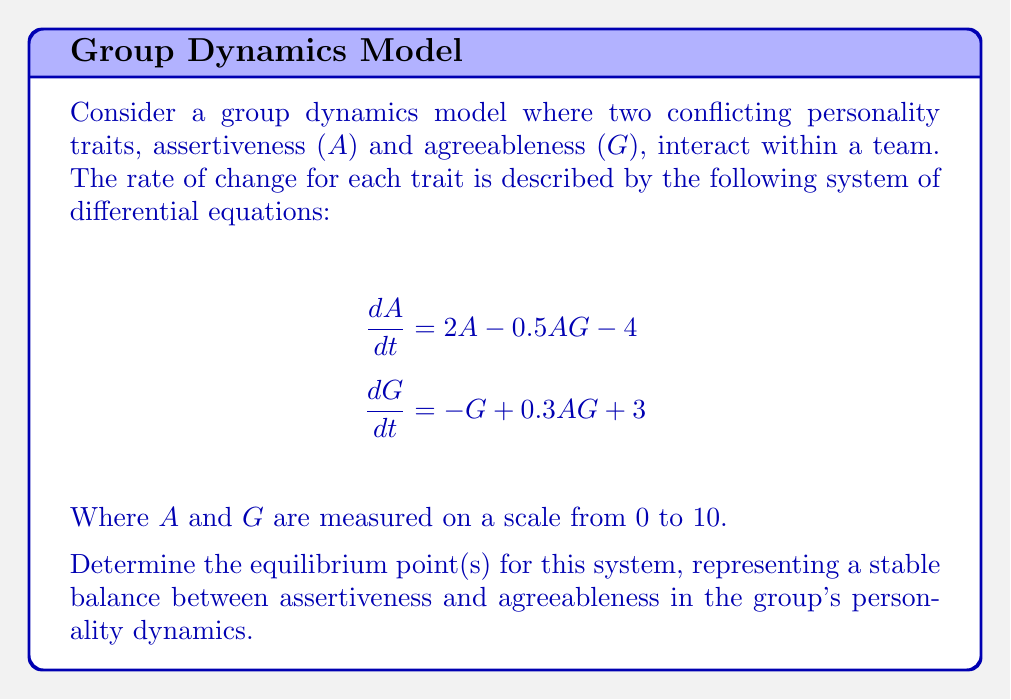Teach me how to tackle this problem. To find the equilibrium point(s), we need to set both equations equal to zero and solve for $A$ and $G$:

1) Set $\frac{dA}{dt} = 0$ and $\frac{dG}{dt} = 0$:

   $$2A - 0.5AG - 4 = 0$$ (Equation 1)
   $$-G + 0.3AG + 3 = 0$$ (Equation 2)

2) From Equation 2:
   $$G = 0.3AG + 3$$

3) Substitute this into Equation 1:
   $$2A - 0.5A(0.3AG + 3) - 4 = 0$$
   $$2A - 0.15A^2G - 1.5A - 4 = 0$$
   $$0.5A - 0.15A^2G - 4 = 0$$

4) Substitute $G = 0.3AG + 3$ into this equation:
   $$0.5A - 0.15A^2(0.3AG + 3) - 4 = 0$$
   $$0.5A - 0.045A^3G - 0.45A^2 - 4 = 0$$

5) Substitute $G = \frac{1}{0.3A}(G - 3)$ from step 2:
   $$0.5A - 0.045A^3(\frac{1}{0.3A}(G - 3)) - 0.45A^2 - 4 = 0$$
   $$0.5A - 0.15A^2 + 0.45A^2 - 0.45A^2 - 4 = 0$$
   $$0.5A - 0.15A^2 - 4 = 0$$

6) Solve this quadratic equation:
   $$0.15A^2 - 0.5A + 4 = 0$$
   $$A = \frac{0.5 \pm \sqrt{0.25 - 4(0.15)(4)}}{2(0.15)}$$
   $$A \approx 5.8054$$

7) Substitute this value of $A$ back into $G = 0.3AG + 3$:
   $$G \approx 0.3(5.8054)G + 3$$
   $$0.7G \approx 4.7416$$
   $$G \approx 6.7737$$

Therefore, the equilibrium point is approximately (5.8054, 6.7737).
Answer: (5.8054, 6.7737) 